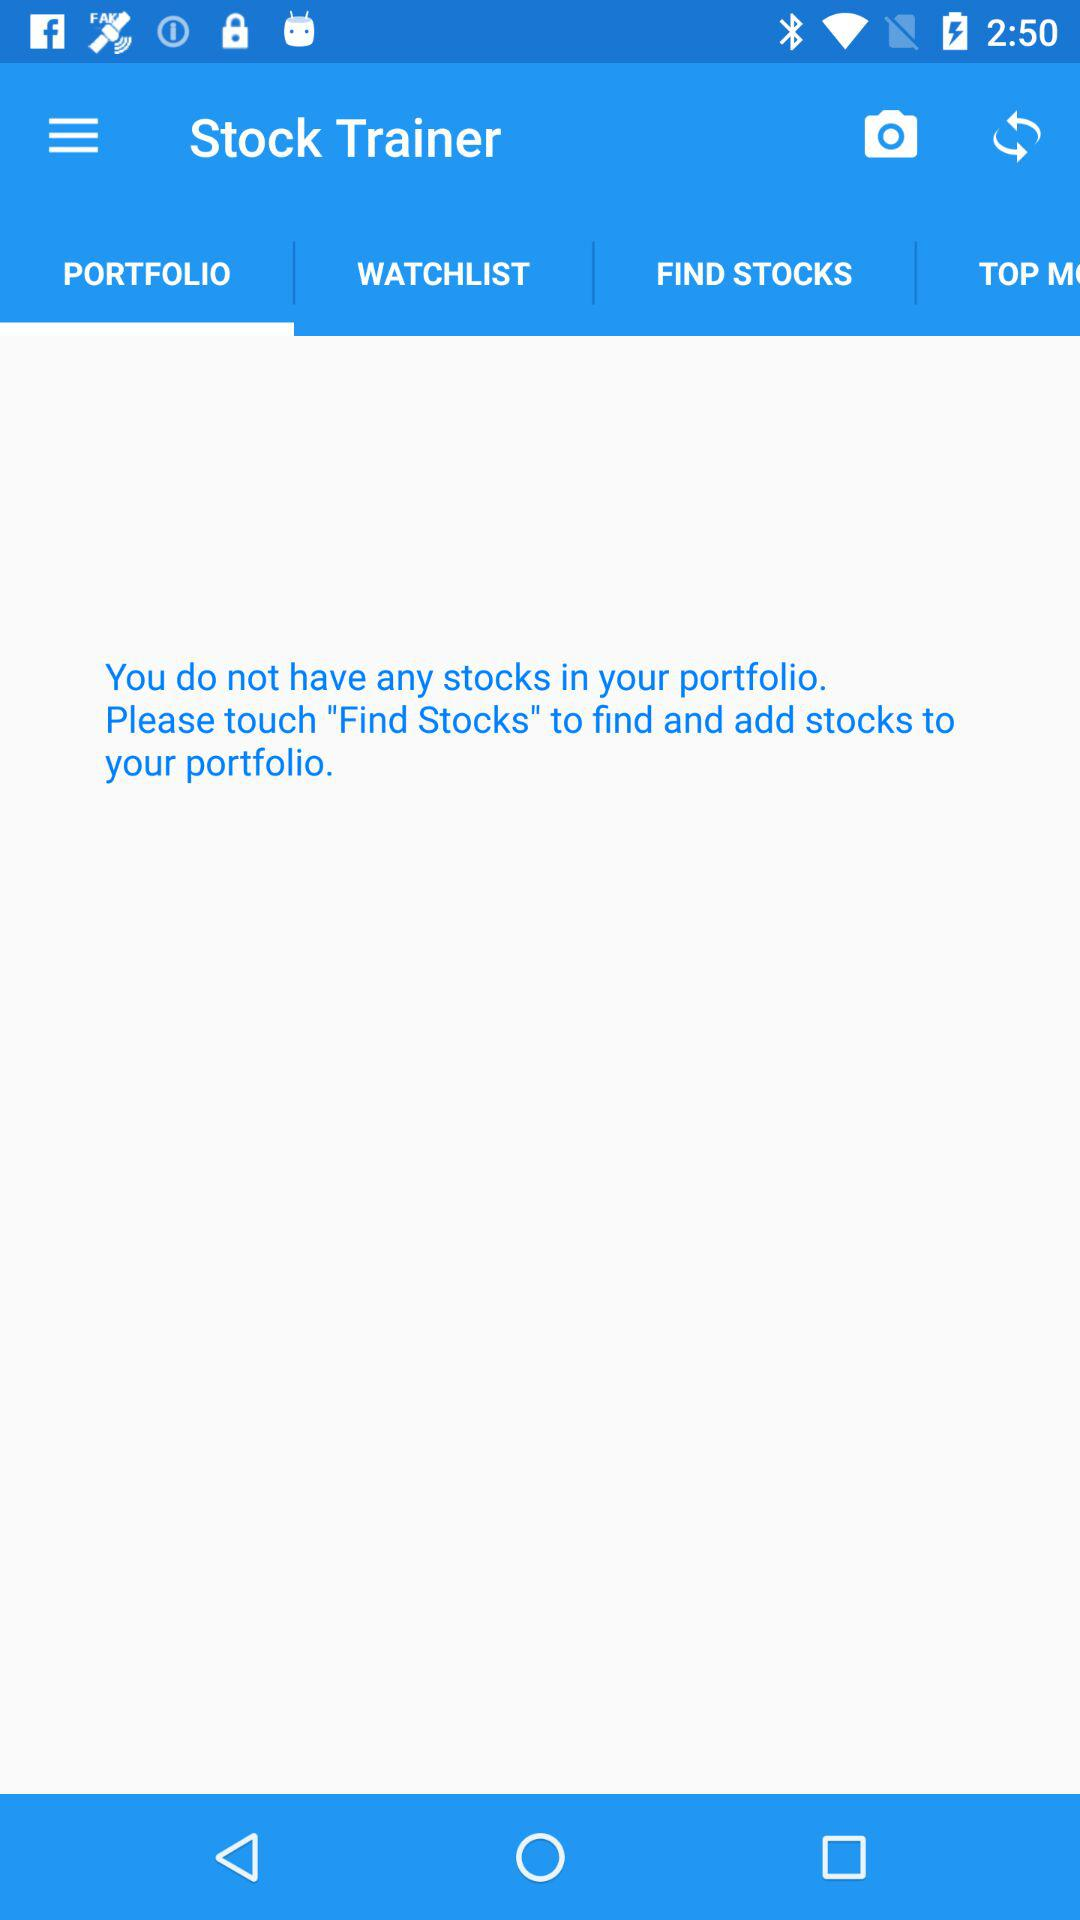Which tab is selected? The selected tab is "PORTFOLIO". 